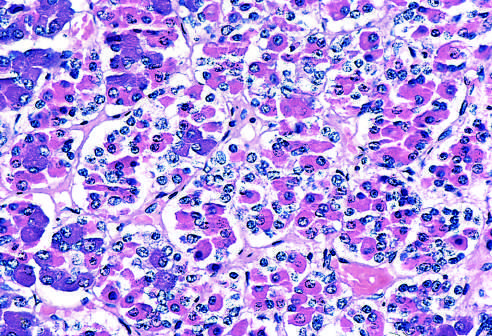re these hormones basophilic (blue), eosinophilic (red), or nonstaining in routine sections stained with hematoxylin and eosin, which allows the various cell types to be identified?
Answer the question using a single word or phrase. Yes 